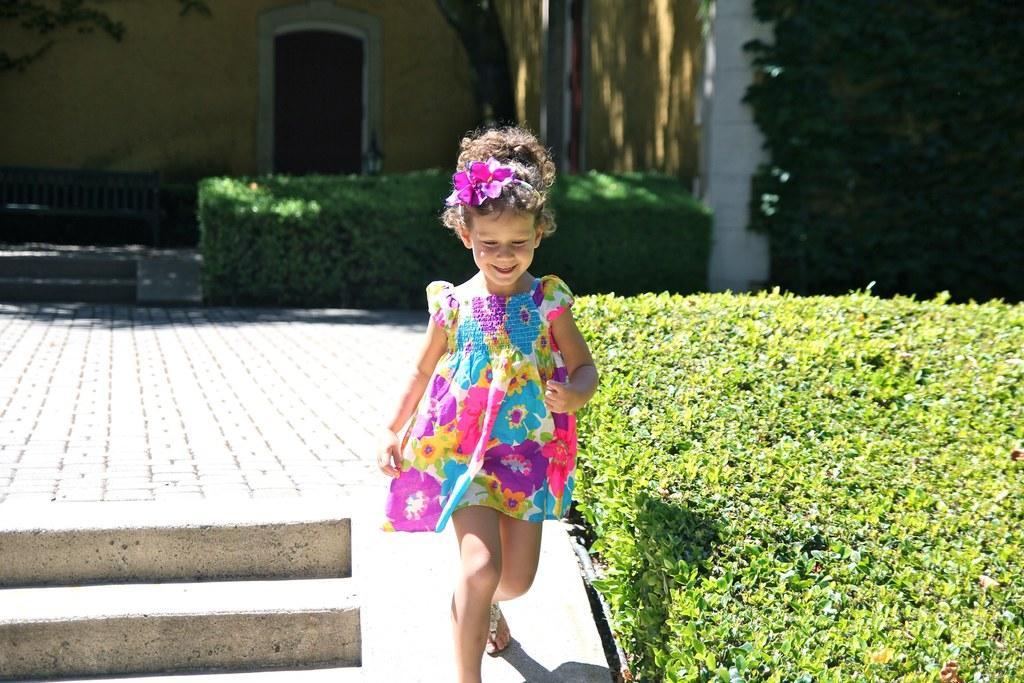Could you give a brief overview of what you see in this image? In the center of this picture there is a girl wearing a floral frock and running on the ground. On the left we can see the pavement and the stairs. On the right we can see the plants, trees and shrubs. In the background we can see the bench and a wall and a door of a building. 